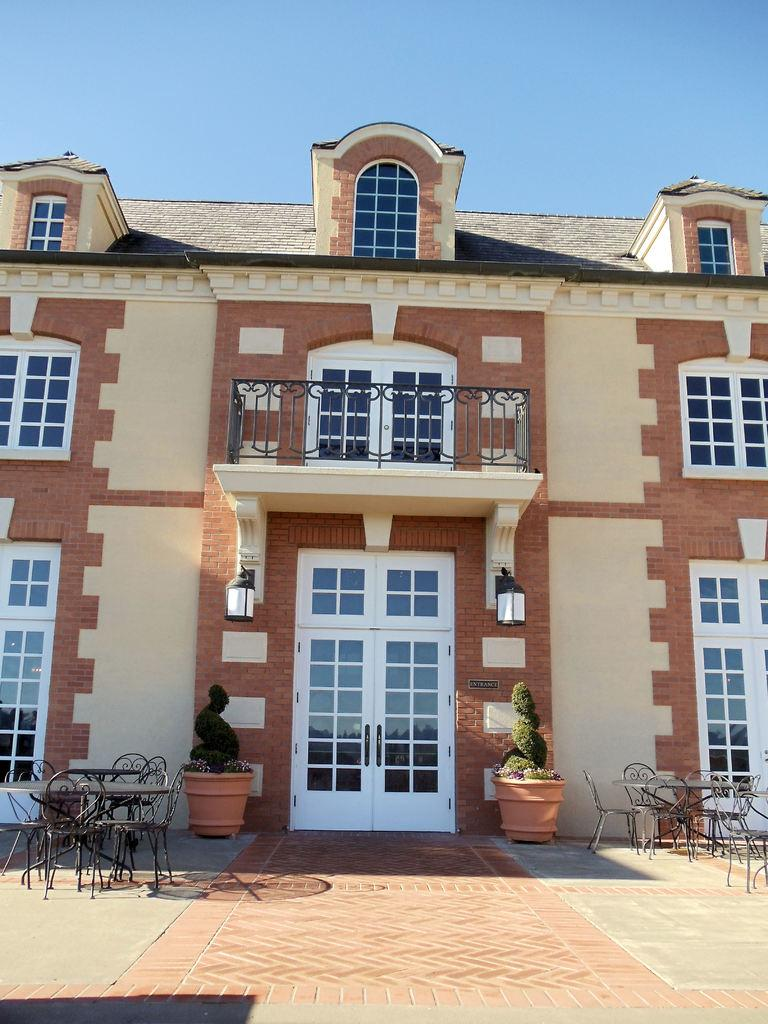What type of furniture is located on the left side of the image? There are chairs and dining tables on the left side of the image. What structure is in the middle of the image? There is a house with glass doors and windows in the middle of the image. What is visible at the top of the image? The sky is visible at the top of the image. How many cakes are on the coast in the image? There is no coast or cake present in the image. 